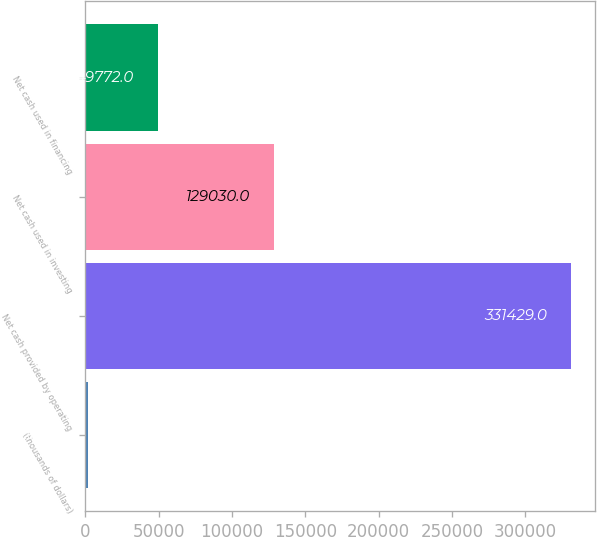Convert chart. <chart><loc_0><loc_0><loc_500><loc_500><bar_chart><fcel>(thousands of dollars)<fcel>Net cash provided by operating<fcel>Net cash used in investing<fcel>Net cash used in financing<nl><fcel>2017<fcel>331429<fcel>129030<fcel>49772<nl></chart> 